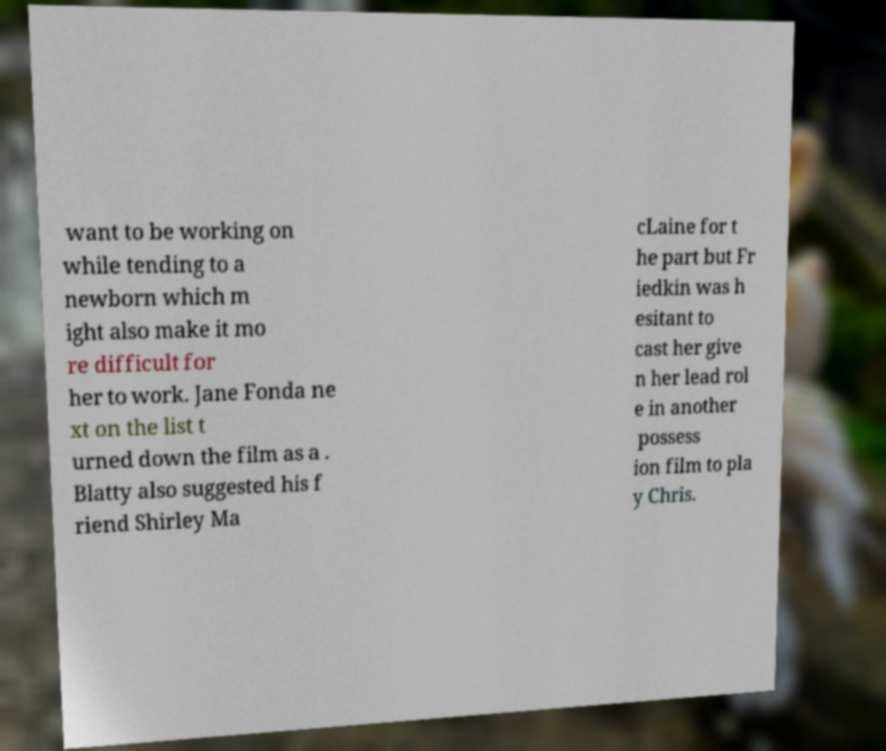Please read and relay the text visible in this image. What does it say? want to be working on while tending to a newborn which m ight also make it mo re difficult for her to work. Jane Fonda ne xt on the list t urned down the film as a . Blatty also suggested his f riend Shirley Ma cLaine for t he part but Fr iedkin was h esitant to cast her give n her lead rol e in another possess ion film to pla y Chris. 